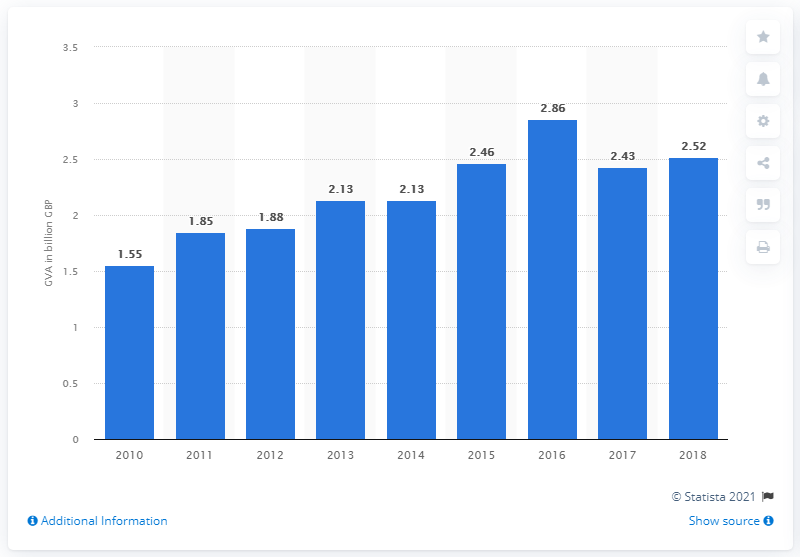Specify some key components in this picture. The gross value added of the fashion industry in the UK in 2018 was approximately 2.52 billion pounds. 